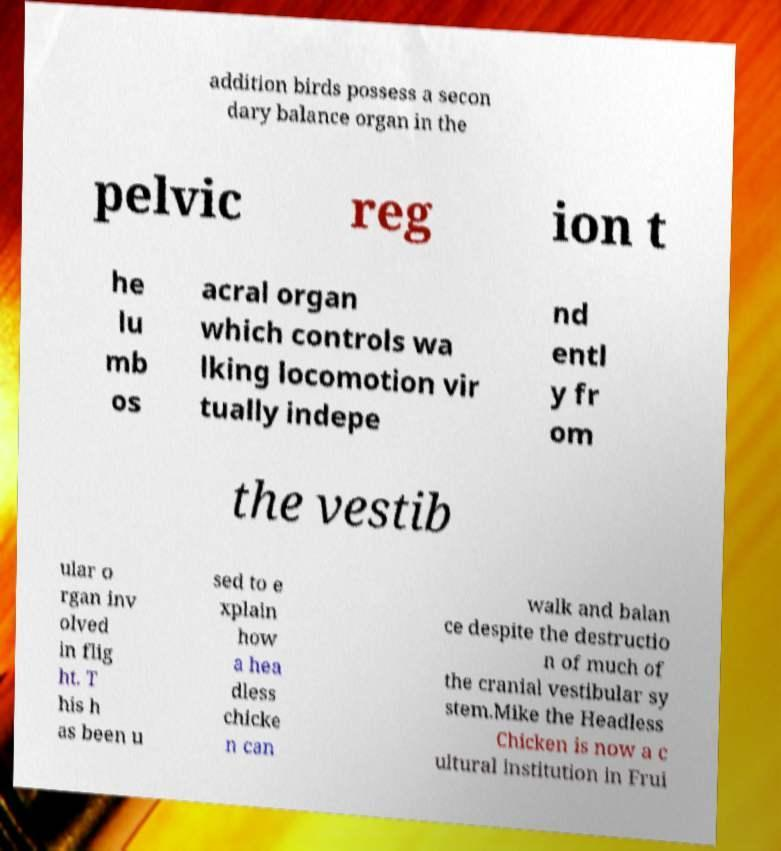Please read and relay the text visible in this image. What does it say? addition birds possess a secon dary balance organ in the pelvic reg ion t he lu mb os acral organ which controls wa lking locomotion vir tually indepe nd entl y fr om the vestib ular o rgan inv olved in flig ht. T his h as been u sed to e xplain how a hea dless chicke n can walk and balan ce despite the destructio n of much of the cranial vestibular sy stem.Mike the Headless Chicken is now a c ultural institution in Frui 